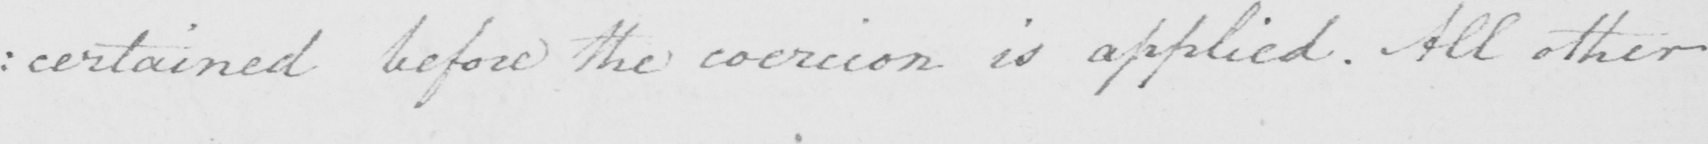What is written in this line of handwriting? : certained before the coercion is applied . All other 